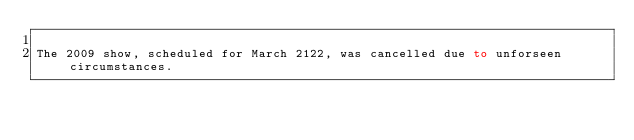Convert code to text. <code><loc_0><loc_0><loc_500><loc_500><_FORTRAN_>
The 2009 show, scheduled for March 2122, was cancelled due to unforseen circumstances.
</code> 